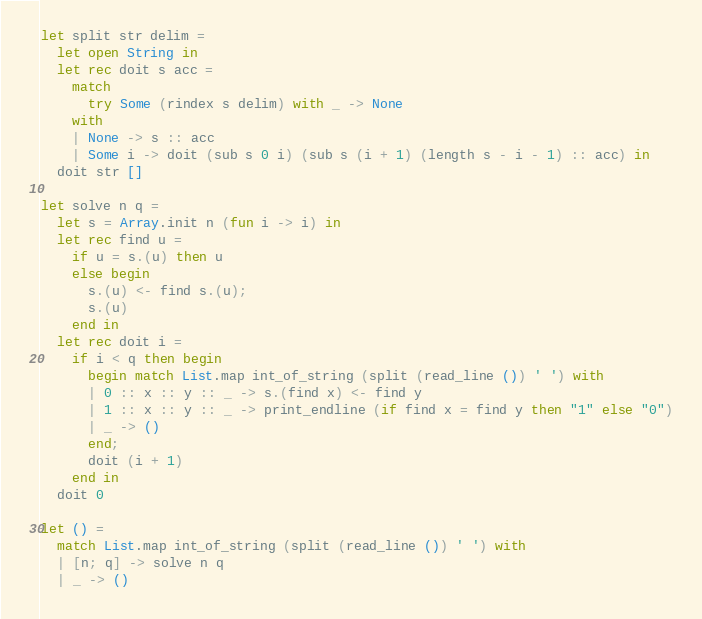Convert code to text. <code><loc_0><loc_0><loc_500><loc_500><_OCaml_>let split str delim =
  let open String in
  let rec doit s acc =
    match
      try Some (rindex s delim) with _ -> None
    with
    | None -> s :: acc
    | Some i -> doit (sub s 0 i) (sub s (i + 1) (length s - i - 1) :: acc) in
  doit str []

let solve n q =
  let s = Array.init n (fun i -> i) in
  let rec find u =
    if u = s.(u) then u
    else begin
      s.(u) <- find s.(u);
      s.(u)
    end in
  let rec doit i =
    if i < q then begin
      begin match List.map int_of_string (split (read_line ()) ' ') with
      | 0 :: x :: y :: _ -> s.(find x) <- find y
      | 1 :: x :: y :: _ -> print_endline (if find x = find y then "1" else "0")
      | _ -> ()
      end;
      doit (i + 1)
    end in
  doit 0

let () =
  match List.map int_of_string (split (read_line ()) ' ') with
  | [n; q] -> solve n q
  | _ -> ()</code> 